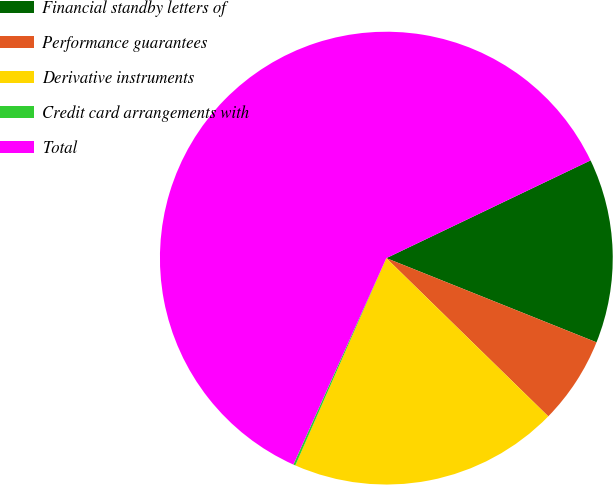<chart> <loc_0><loc_0><loc_500><loc_500><pie_chart><fcel>Financial standby letters of<fcel>Performance guarantees<fcel>Derivative instruments<fcel>Credit card arrangements with<fcel>Total<nl><fcel>13.17%<fcel>6.25%<fcel>19.27%<fcel>0.15%<fcel>61.16%<nl></chart> 